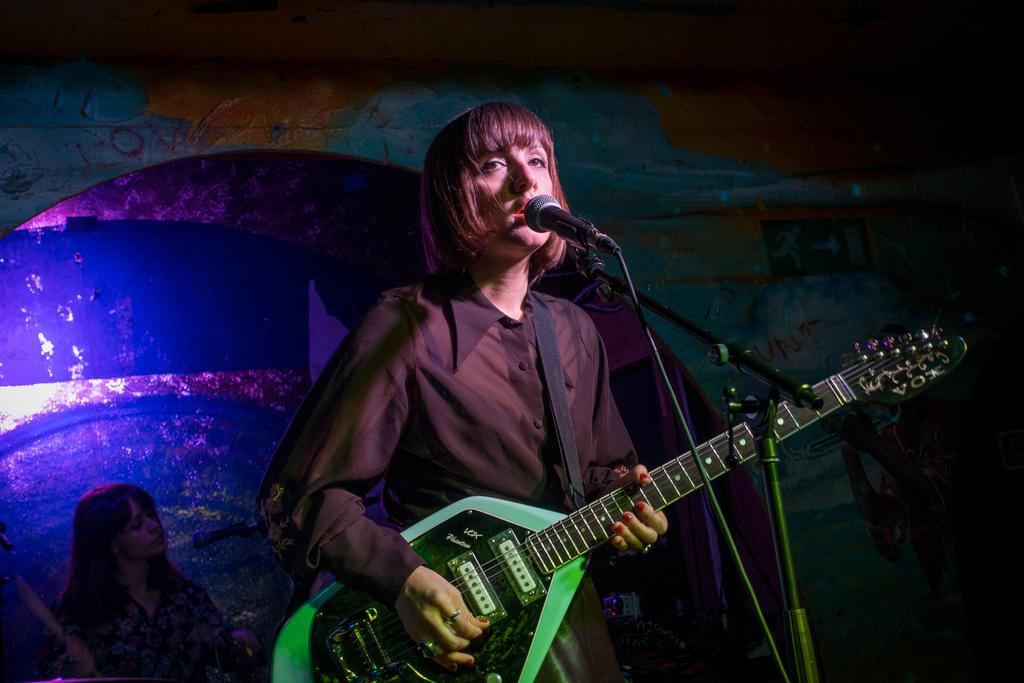What is the woman in the image doing? The woman is singing on a mic and playing a guitar. Is there anyone else in the image? Yes, there is another woman behind her. What can be seen in the background of the image? There is a wall in the background. How many men are playing musical instruments in the image? There are no men present in the image, and no musical instruments other than the guitar are visible. Can you see a kitten playing with a heart in the image? No, there is no kitten or heart present in the image. 